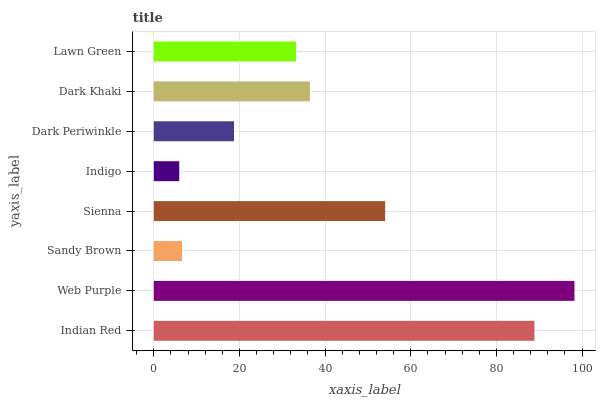Is Indigo the minimum?
Answer yes or no. Yes. Is Web Purple the maximum?
Answer yes or no. Yes. Is Sandy Brown the minimum?
Answer yes or no. No. Is Sandy Brown the maximum?
Answer yes or no. No. Is Web Purple greater than Sandy Brown?
Answer yes or no. Yes. Is Sandy Brown less than Web Purple?
Answer yes or no. Yes. Is Sandy Brown greater than Web Purple?
Answer yes or no. No. Is Web Purple less than Sandy Brown?
Answer yes or no. No. Is Dark Khaki the high median?
Answer yes or no. Yes. Is Lawn Green the low median?
Answer yes or no. Yes. Is Sandy Brown the high median?
Answer yes or no. No. Is Sienna the low median?
Answer yes or no. No. 